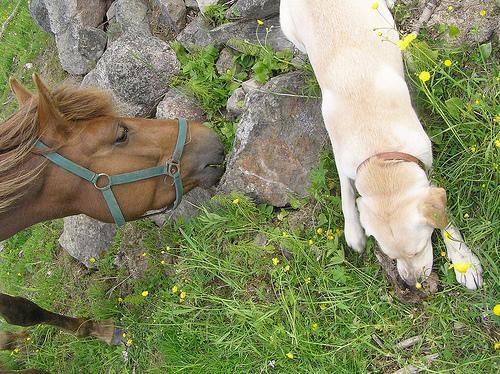How many ears are visible?
Give a very brief answer. 4. 